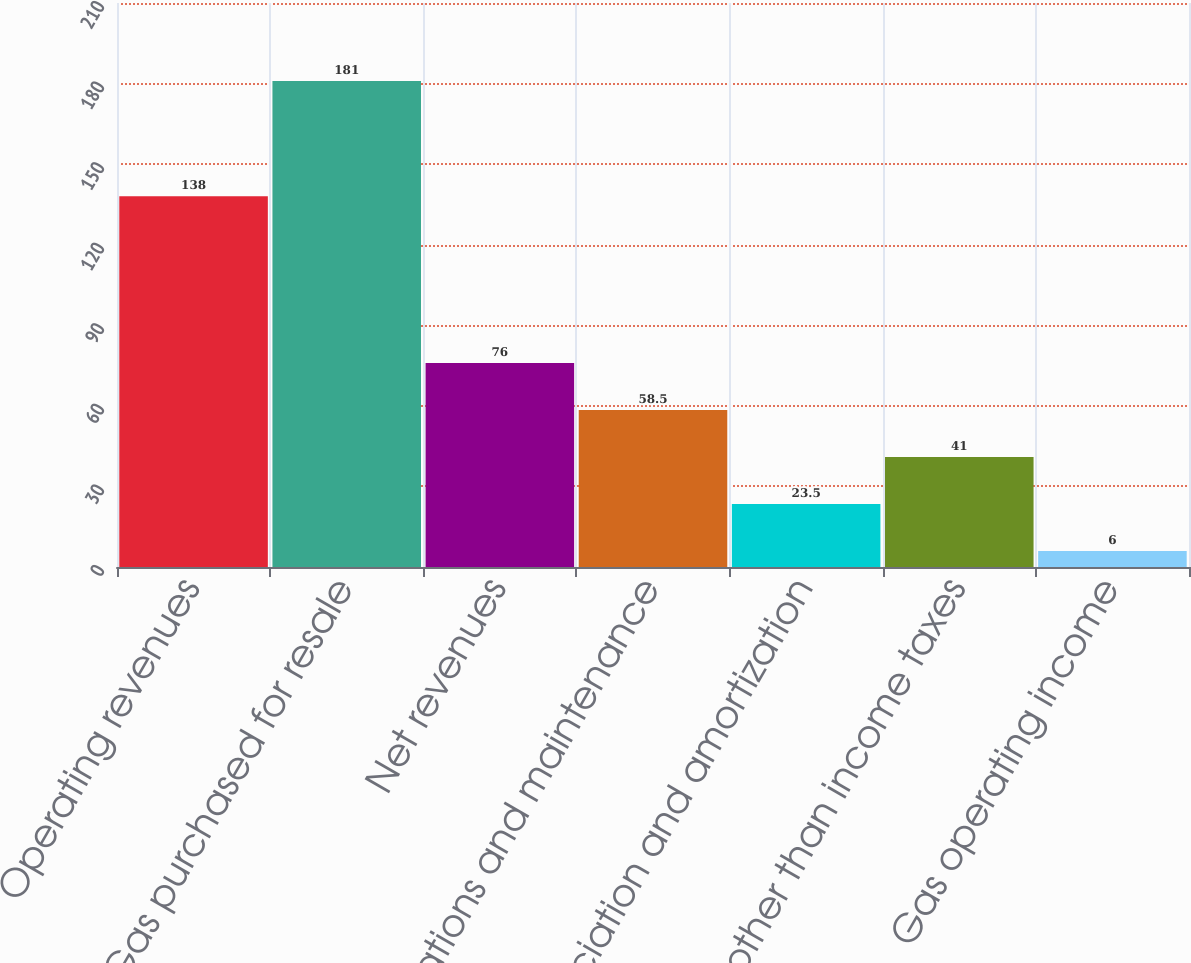<chart> <loc_0><loc_0><loc_500><loc_500><bar_chart><fcel>Operating revenues<fcel>Gas purchased for resale<fcel>Net revenues<fcel>Operations and maintenance<fcel>Depreciation and amortization<fcel>Taxes other than income taxes<fcel>Gas operating income<nl><fcel>138<fcel>181<fcel>76<fcel>58.5<fcel>23.5<fcel>41<fcel>6<nl></chart> 